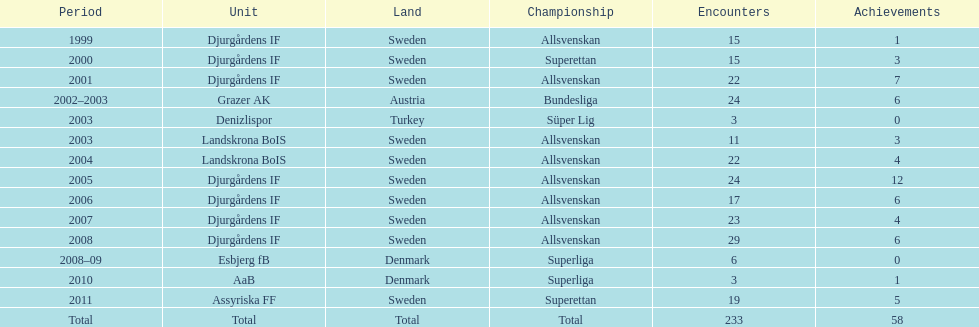How many teams had above 20 matches in the season? 6. 